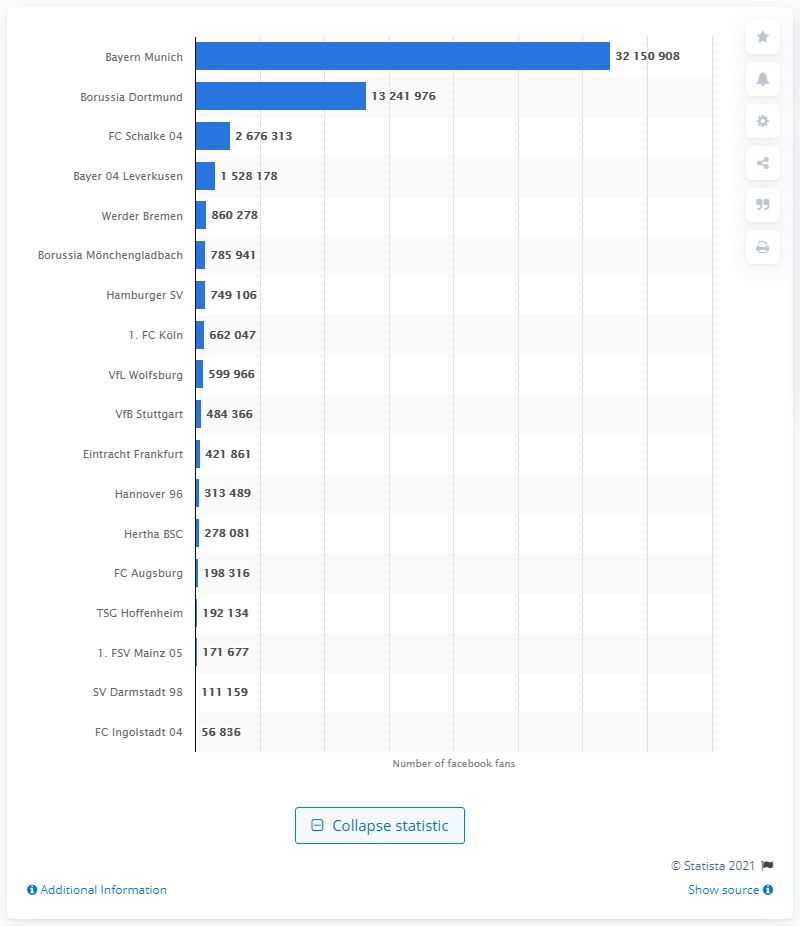List a handful of essential elements in this visual. As of September 2015, Bayern Munich had 32,150,908 Facebook likes. 